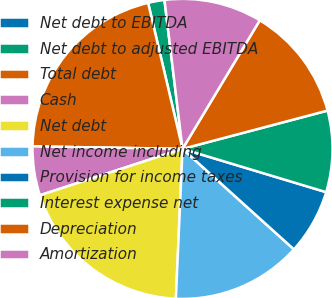Convert chart to OTSL. <chart><loc_0><loc_0><loc_500><loc_500><pie_chart><fcel>Net debt to EBITDA<fcel>Net debt to adjusted EBITDA<fcel>Total debt<fcel>Cash<fcel>Net debt<fcel>Net income including<fcel>Provision for income taxes<fcel>Interest expense net<fcel>Depreciation<fcel>Amortization<nl><fcel>0.01%<fcel>1.76%<fcel>21.05%<fcel>5.27%<fcel>19.29%<fcel>14.03%<fcel>7.02%<fcel>8.77%<fcel>12.28%<fcel>10.53%<nl></chart> 